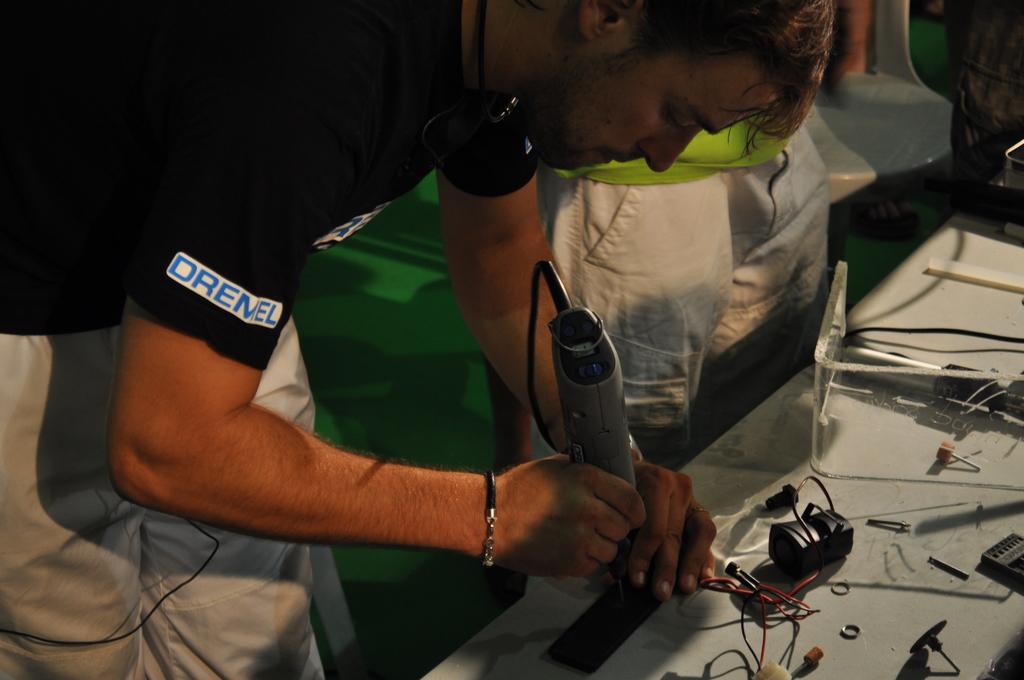Does he have a dremel shirt on?
Your response must be concise. Yes. 